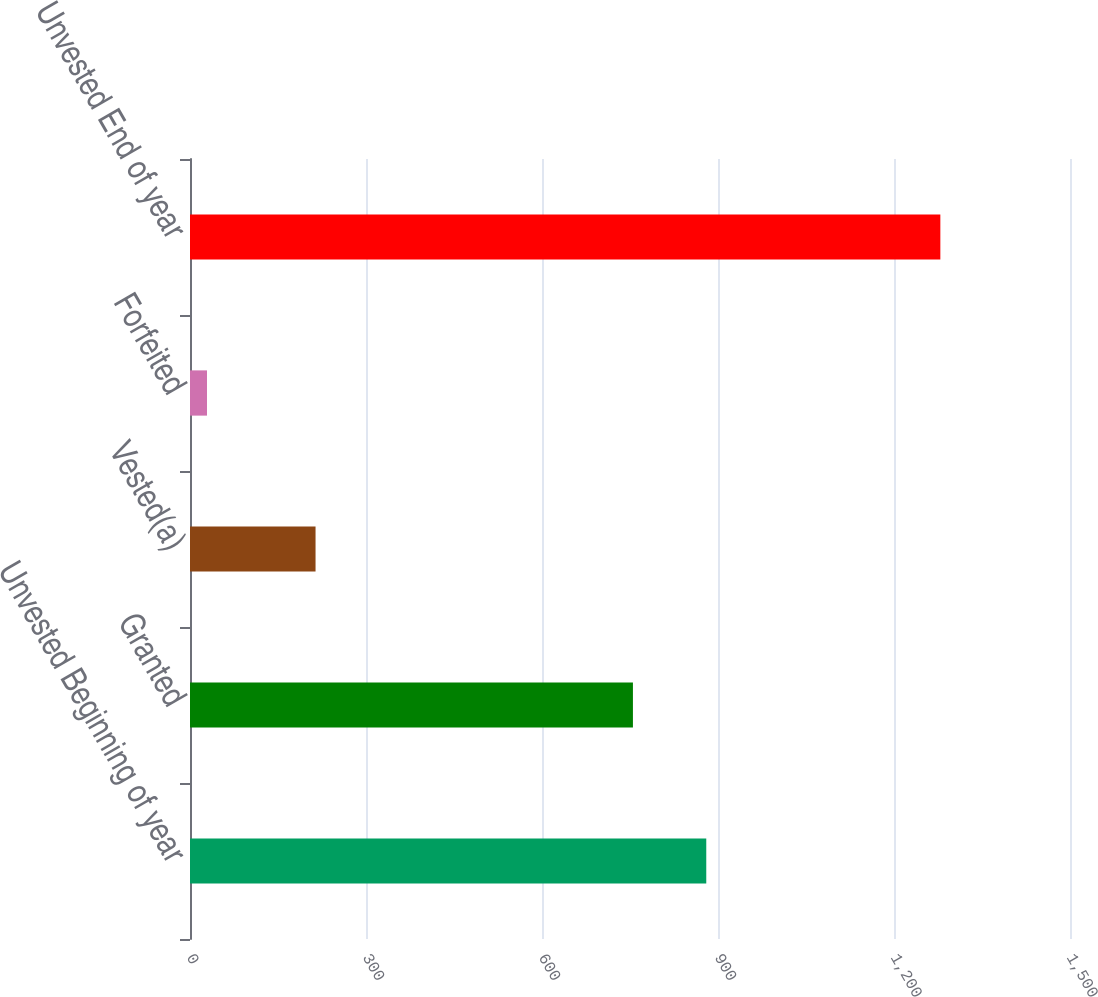Convert chart to OTSL. <chart><loc_0><loc_0><loc_500><loc_500><bar_chart><fcel>Unvested Beginning of year<fcel>Granted<fcel>Vested(a)<fcel>Forfeited<fcel>Unvested End of year<nl><fcel>880<fcel>755<fcel>214<fcel>29<fcel>1279<nl></chart> 